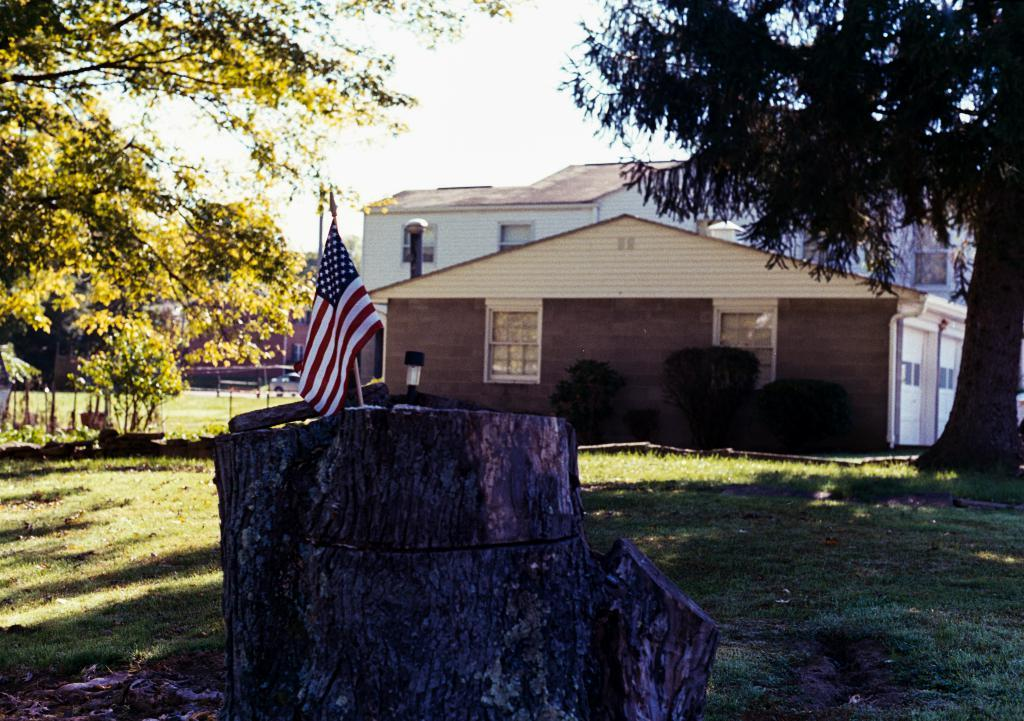What is attached to the tree trunk in the image? There is a flag on a tree trunk in the image. What type of vegetation can be seen in the image? There is grass visible in the image, and there are also trees. What types of man-made structures are present in the image? There are buildings with windows in the image. What can be seen in the background of the image? The sky is visible in the background of the image. What other objects or features can be seen in the image? There are vehicles in the image. Can you describe the view of the seashore from the image? There is no seashore visible in the image; it features a flag on a tree trunk, grass, trees, buildings, vehicles, and the sky. How many horses are present in the image? There are no horses present in the image. 